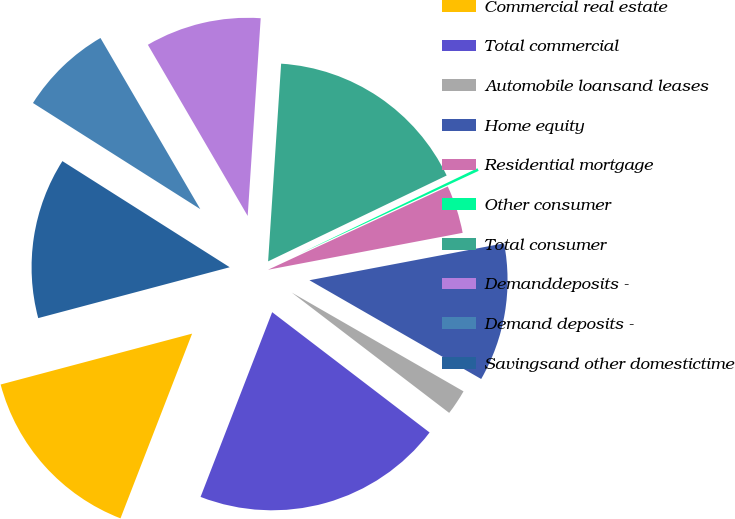<chart> <loc_0><loc_0><loc_500><loc_500><pie_chart><fcel>Commercial real estate<fcel>Total commercial<fcel>Automobile loansand leases<fcel>Home equity<fcel>Residential mortgage<fcel>Other consumer<fcel>Total consumer<fcel>Demanddeposits -<fcel>Demand deposits -<fcel>Savingsand other domestictime<nl><fcel>14.98%<fcel>20.5%<fcel>2.08%<fcel>11.29%<fcel>3.92%<fcel>0.23%<fcel>16.82%<fcel>9.45%<fcel>7.6%<fcel>13.13%<nl></chart> 